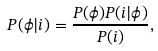Convert formula to latex. <formula><loc_0><loc_0><loc_500><loc_500>P ( \phi | i ) = \frac { P ( \phi ) P ( i | \phi ) } { P ( i ) } ,</formula> 